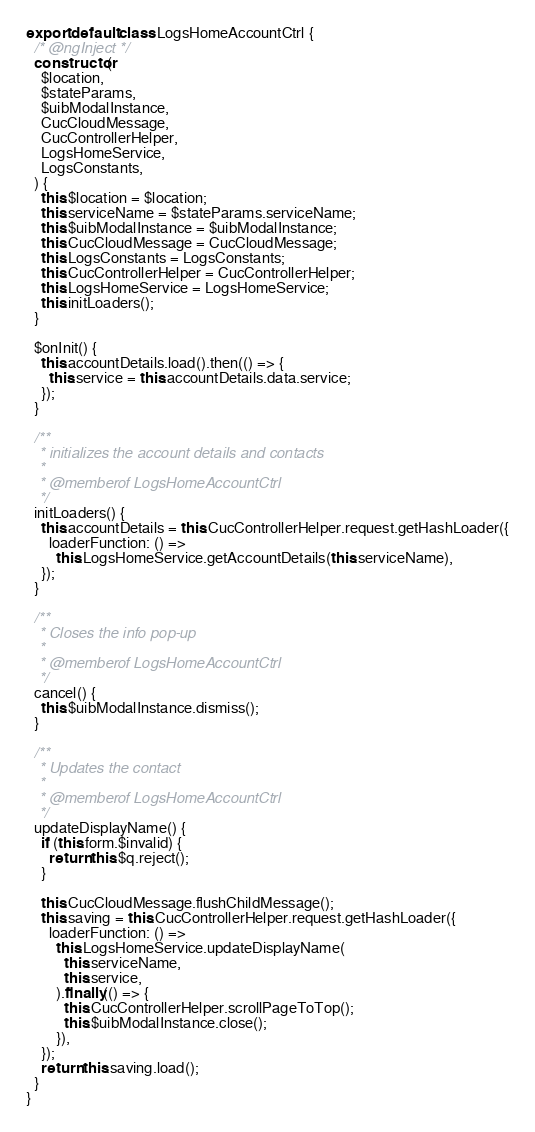Convert code to text. <code><loc_0><loc_0><loc_500><loc_500><_JavaScript_>export default class LogsHomeAccountCtrl {
  /* @ngInject */
  constructor(
    $location,
    $stateParams,
    $uibModalInstance,
    CucCloudMessage,
    CucControllerHelper,
    LogsHomeService,
    LogsConstants,
  ) {
    this.$location = $location;
    this.serviceName = $stateParams.serviceName;
    this.$uibModalInstance = $uibModalInstance;
    this.CucCloudMessage = CucCloudMessage;
    this.LogsConstants = LogsConstants;
    this.CucControllerHelper = CucControllerHelper;
    this.LogsHomeService = LogsHomeService;
    this.initLoaders();
  }

  $onInit() {
    this.accountDetails.load().then(() => {
      this.service = this.accountDetails.data.service;
    });
  }

  /**
   * initializes the account details and contacts
   *
   * @memberof LogsHomeAccountCtrl
   */
  initLoaders() {
    this.accountDetails = this.CucControllerHelper.request.getHashLoader({
      loaderFunction: () =>
        this.LogsHomeService.getAccountDetails(this.serviceName),
    });
  }

  /**
   * Closes the info pop-up
   *
   * @memberof LogsHomeAccountCtrl
   */
  cancel() {
    this.$uibModalInstance.dismiss();
  }

  /**
   * Updates the contact
   *
   * @memberof LogsHomeAccountCtrl
   */
  updateDisplayName() {
    if (this.form.$invalid) {
      return this.$q.reject();
    }

    this.CucCloudMessage.flushChildMessage();
    this.saving = this.CucControllerHelper.request.getHashLoader({
      loaderFunction: () =>
        this.LogsHomeService.updateDisplayName(
          this.serviceName,
          this.service,
        ).finally(() => {
          this.CucControllerHelper.scrollPageToTop();
          this.$uibModalInstance.close();
        }),
    });
    return this.saving.load();
  }
}
</code> 